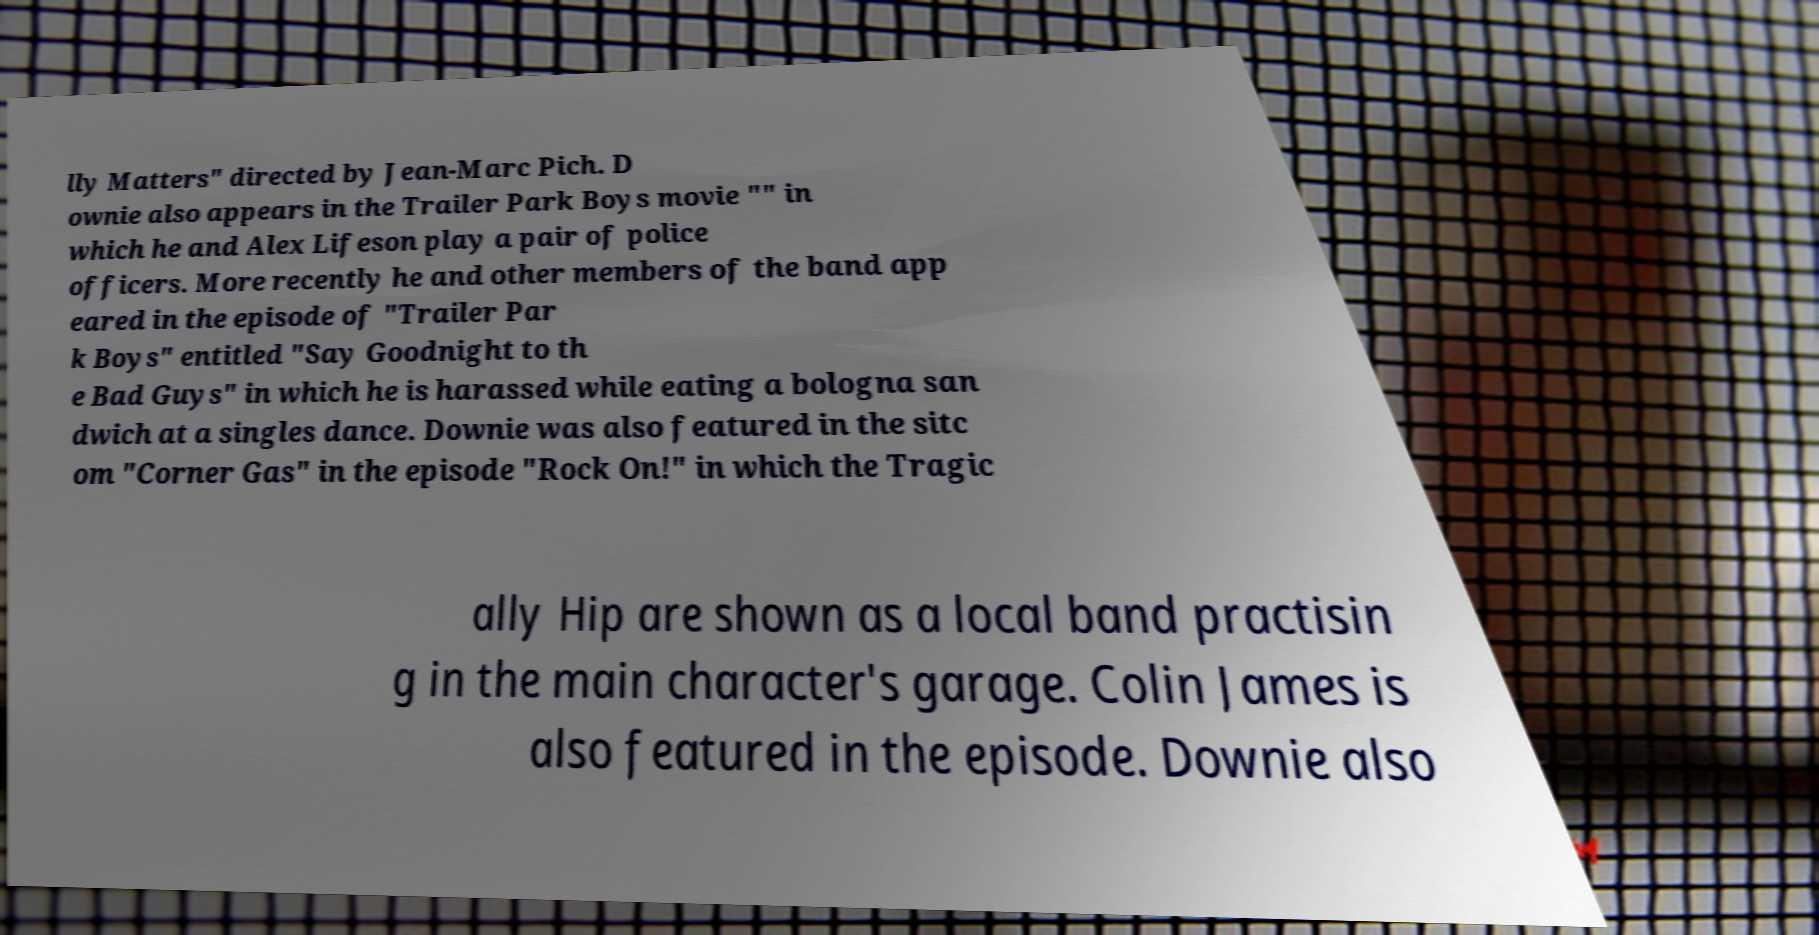Can you read and provide the text displayed in the image?This photo seems to have some interesting text. Can you extract and type it out for me? lly Matters" directed by Jean-Marc Pich. D ownie also appears in the Trailer Park Boys movie "" in which he and Alex Lifeson play a pair of police officers. More recently he and other members of the band app eared in the episode of "Trailer Par k Boys" entitled "Say Goodnight to th e Bad Guys" in which he is harassed while eating a bologna san dwich at a singles dance. Downie was also featured in the sitc om "Corner Gas" in the episode "Rock On!" in which the Tragic ally Hip are shown as a local band practisin g in the main character's garage. Colin James is also featured in the episode. Downie also 